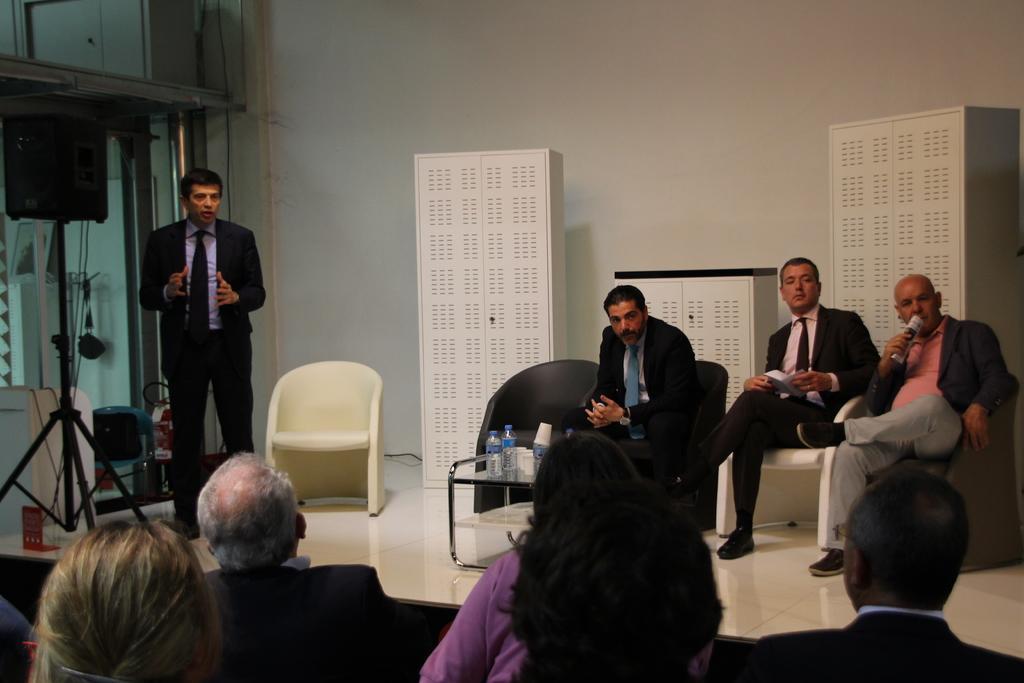Please provide a concise description of this image. In this image we can see persons, chairs, table, water bottle, glasses on the dais. At the bottom of the image we can see person and chairs. On the left side of the image we can see speaker, stand, chair and person. In the background we can see wall and cupboards. 